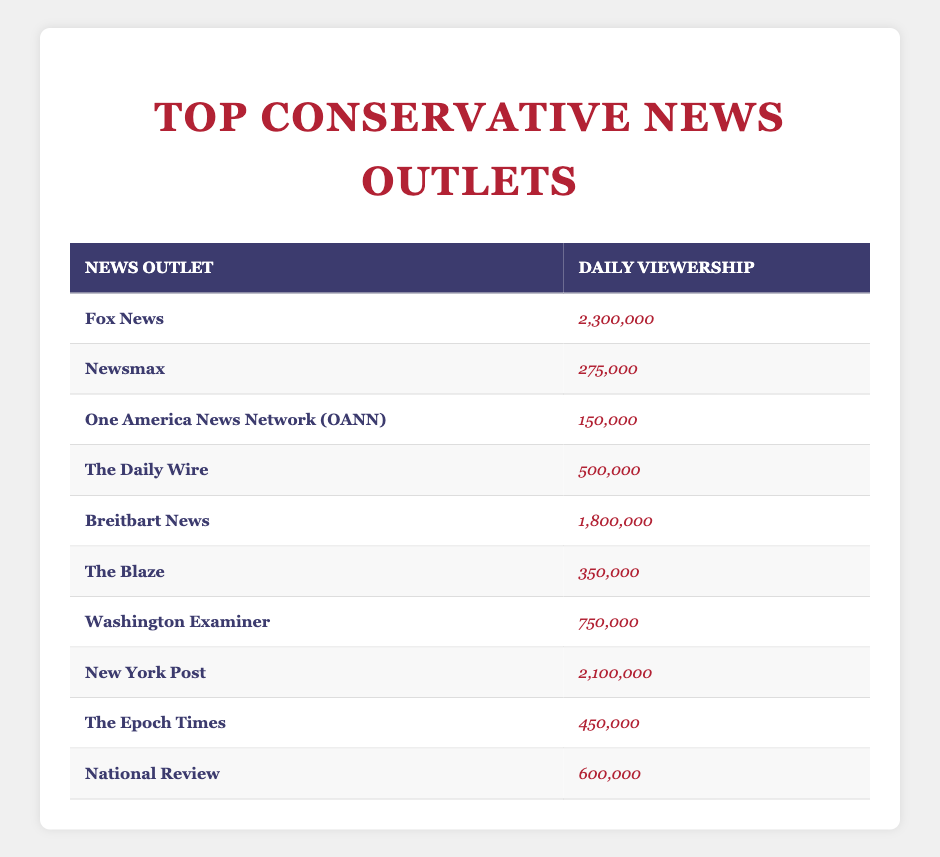What is the daily viewership of Fox News? The table lists Fox News' daily viewership in the respective column. It shows "2,300,000" as the corresponding value for Fox News.
Answer: 2,300,000 Which conservative news outlet has the lowest daily viewership? By looking through the "Daily Viewership" column, One America News Network (OANN) has the lowest figure, which is "150,000."
Answer: One America News Network (OANN) What is the total daily viewership of Fox News and New York Post combined? First, identify the viewership numbers: Fox News has "2,300,000" and New York Post has "2,100,000." Adding these gives 2,300,000 + 2,100,000 = 4,400,000.
Answer: 4,400,000 Is Breitbart News' daily viewership greater than that of The Daily Wire? Breitbart News has a daily viewership of "1,800,000" and The Daily Wire has "500,000." Since 1,800,000 is greater than 500,000, the statement is true.
Answer: Yes What is the average daily viewership across all listed news outlets? First, sum the viewership numbers: 2,300,000 + 275,000 + 150,000 + 500,000 + 1,800,000 + 350,000 + 750,000 + 2,100,000 + 450,000 + 600,000 = 10,875,000. There are 10 outlets, so the average is 10,875,000 / 10 = 1,087,500.
Answer: 1,087,500 